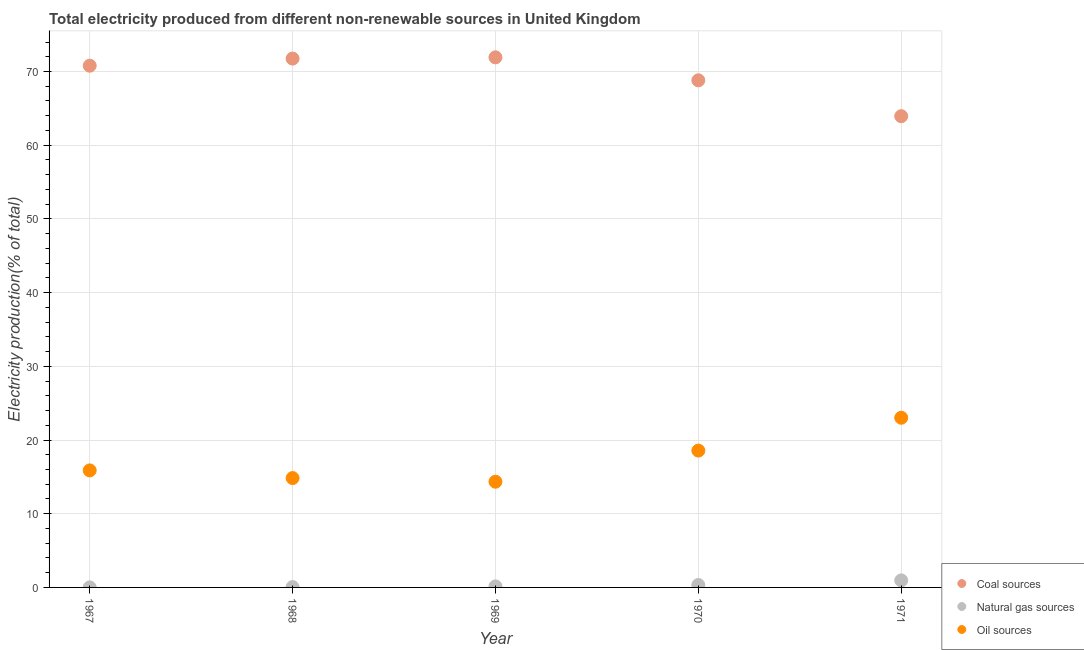How many different coloured dotlines are there?
Offer a very short reply. 3. What is the percentage of electricity produced by coal in 1970?
Your answer should be very brief. 68.81. Across all years, what is the maximum percentage of electricity produced by natural gas?
Provide a succinct answer. 0.96. Across all years, what is the minimum percentage of electricity produced by oil sources?
Provide a short and direct response. 14.34. In which year was the percentage of electricity produced by coal minimum?
Ensure brevity in your answer.  1971. What is the total percentage of electricity produced by natural gas in the graph?
Provide a short and direct response. 1.48. What is the difference between the percentage of electricity produced by coal in 1967 and that in 1971?
Your answer should be very brief. 6.85. What is the difference between the percentage of electricity produced by coal in 1967 and the percentage of electricity produced by oil sources in 1970?
Provide a succinct answer. 52.22. What is the average percentage of electricity produced by natural gas per year?
Your answer should be compact. 0.3. In the year 1968, what is the difference between the percentage of electricity produced by oil sources and percentage of electricity produced by coal?
Keep it short and to the point. -56.91. What is the ratio of the percentage of electricity produced by coal in 1967 to that in 1970?
Provide a short and direct response. 1.03. What is the difference between the highest and the second highest percentage of electricity produced by natural gas?
Your answer should be very brief. 0.62. What is the difference between the highest and the lowest percentage of electricity produced by natural gas?
Your response must be concise. 0.95. Is the sum of the percentage of electricity produced by coal in 1967 and 1968 greater than the maximum percentage of electricity produced by natural gas across all years?
Keep it short and to the point. Yes. Does the percentage of electricity produced by oil sources monotonically increase over the years?
Your answer should be compact. No. How many years are there in the graph?
Offer a terse response. 5. Are the values on the major ticks of Y-axis written in scientific E-notation?
Give a very brief answer. No. Does the graph contain any zero values?
Make the answer very short. No. Does the graph contain grids?
Ensure brevity in your answer.  Yes. How many legend labels are there?
Your answer should be compact. 3. How are the legend labels stacked?
Give a very brief answer. Vertical. What is the title of the graph?
Make the answer very short. Total electricity produced from different non-renewable sources in United Kingdom. What is the Electricity production(% of total) in Coal sources in 1967?
Ensure brevity in your answer.  70.79. What is the Electricity production(% of total) of Natural gas sources in 1967?
Make the answer very short. 0.01. What is the Electricity production(% of total) of Oil sources in 1967?
Ensure brevity in your answer.  15.88. What is the Electricity production(% of total) of Coal sources in 1968?
Ensure brevity in your answer.  71.75. What is the Electricity production(% of total) of Natural gas sources in 1968?
Give a very brief answer. 0.05. What is the Electricity production(% of total) of Oil sources in 1968?
Your response must be concise. 14.84. What is the Electricity production(% of total) in Coal sources in 1969?
Your answer should be very brief. 71.92. What is the Electricity production(% of total) in Natural gas sources in 1969?
Offer a terse response. 0.14. What is the Electricity production(% of total) in Oil sources in 1969?
Provide a short and direct response. 14.34. What is the Electricity production(% of total) of Coal sources in 1970?
Keep it short and to the point. 68.81. What is the Electricity production(% of total) in Natural gas sources in 1970?
Offer a very short reply. 0.33. What is the Electricity production(% of total) of Oil sources in 1970?
Your response must be concise. 18.57. What is the Electricity production(% of total) of Coal sources in 1971?
Provide a succinct answer. 63.94. What is the Electricity production(% of total) in Natural gas sources in 1971?
Keep it short and to the point. 0.96. What is the Electricity production(% of total) of Oil sources in 1971?
Your answer should be compact. 23.02. Across all years, what is the maximum Electricity production(% of total) in Coal sources?
Ensure brevity in your answer.  71.92. Across all years, what is the maximum Electricity production(% of total) in Natural gas sources?
Ensure brevity in your answer.  0.96. Across all years, what is the maximum Electricity production(% of total) in Oil sources?
Offer a very short reply. 23.02. Across all years, what is the minimum Electricity production(% of total) of Coal sources?
Provide a succinct answer. 63.94. Across all years, what is the minimum Electricity production(% of total) of Natural gas sources?
Keep it short and to the point. 0.01. Across all years, what is the minimum Electricity production(% of total) of Oil sources?
Offer a very short reply. 14.34. What is the total Electricity production(% of total) of Coal sources in the graph?
Give a very brief answer. 347.21. What is the total Electricity production(% of total) of Natural gas sources in the graph?
Provide a short and direct response. 1.48. What is the total Electricity production(% of total) in Oil sources in the graph?
Keep it short and to the point. 86.65. What is the difference between the Electricity production(% of total) in Coal sources in 1967 and that in 1968?
Keep it short and to the point. -0.96. What is the difference between the Electricity production(% of total) in Natural gas sources in 1967 and that in 1968?
Give a very brief answer. -0.04. What is the difference between the Electricity production(% of total) of Oil sources in 1967 and that in 1968?
Ensure brevity in your answer.  1.04. What is the difference between the Electricity production(% of total) of Coal sources in 1967 and that in 1969?
Your answer should be compact. -1.13. What is the difference between the Electricity production(% of total) of Natural gas sources in 1967 and that in 1969?
Make the answer very short. -0.14. What is the difference between the Electricity production(% of total) in Oil sources in 1967 and that in 1969?
Your answer should be very brief. 1.53. What is the difference between the Electricity production(% of total) of Coal sources in 1967 and that in 1970?
Make the answer very short. 1.98. What is the difference between the Electricity production(% of total) in Natural gas sources in 1967 and that in 1970?
Your response must be concise. -0.32. What is the difference between the Electricity production(% of total) of Oil sources in 1967 and that in 1970?
Your response must be concise. -2.69. What is the difference between the Electricity production(% of total) of Coal sources in 1967 and that in 1971?
Ensure brevity in your answer.  6.85. What is the difference between the Electricity production(% of total) of Natural gas sources in 1967 and that in 1971?
Your answer should be compact. -0.95. What is the difference between the Electricity production(% of total) in Oil sources in 1967 and that in 1971?
Make the answer very short. -7.15. What is the difference between the Electricity production(% of total) of Coal sources in 1968 and that in 1969?
Provide a short and direct response. -0.17. What is the difference between the Electricity production(% of total) of Natural gas sources in 1968 and that in 1969?
Offer a terse response. -0.09. What is the difference between the Electricity production(% of total) of Oil sources in 1968 and that in 1969?
Provide a short and direct response. 0.5. What is the difference between the Electricity production(% of total) in Coal sources in 1968 and that in 1970?
Make the answer very short. 2.95. What is the difference between the Electricity production(% of total) in Natural gas sources in 1968 and that in 1970?
Keep it short and to the point. -0.28. What is the difference between the Electricity production(% of total) of Oil sources in 1968 and that in 1970?
Give a very brief answer. -3.73. What is the difference between the Electricity production(% of total) of Coal sources in 1968 and that in 1971?
Give a very brief answer. 7.81. What is the difference between the Electricity production(% of total) in Natural gas sources in 1968 and that in 1971?
Offer a terse response. -0.91. What is the difference between the Electricity production(% of total) in Oil sources in 1968 and that in 1971?
Ensure brevity in your answer.  -8.18. What is the difference between the Electricity production(% of total) of Coal sources in 1969 and that in 1970?
Keep it short and to the point. 3.12. What is the difference between the Electricity production(% of total) in Natural gas sources in 1969 and that in 1970?
Offer a terse response. -0.19. What is the difference between the Electricity production(% of total) in Oil sources in 1969 and that in 1970?
Make the answer very short. -4.22. What is the difference between the Electricity production(% of total) in Coal sources in 1969 and that in 1971?
Offer a terse response. 7.99. What is the difference between the Electricity production(% of total) of Natural gas sources in 1969 and that in 1971?
Offer a terse response. -0.81. What is the difference between the Electricity production(% of total) of Oil sources in 1969 and that in 1971?
Offer a very short reply. -8.68. What is the difference between the Electricity production(% of total) of Coal sources in 1970 and that in 1971?
Ensure brevity in your answer.  4.87. What is the difference between the Electricity production(% of total) of Natural gas sources in 1970 and that in 1971?
Give a very brief answer. -0.62. What is the difference between the Electricity production(% of total) of Oil sources in 1970 and that in 1971?
Keep it short and to the point. -4.46. What is the difference between the Electricity production(% of total) of Coal sources in 1967 and the Electricity production(% of total) of Natural gas sources in 1968?
Your response must be concise. 70.74. What is the difference between the Electricity production(% of total) in Coal sources in 1967 and the Electricity production(% of total) in Oil sources in 1968?
Provide a succinct answer. 55.95. What is the difference between the Electricity production(% of total) of Natural gas sources in 1967 and the Electricity production(% of total) of Oil sources in 1968?
Make the answer very short. -14.83. What is the difference between the Electricity production(% of total) in Coal sources in 1967 and the Electricity production(% of total) in Natural gas sources in 1969?
Offer a very short reply. 70.65. What is the difference between the Electricity production(% of total) of Coal sources in 1967 and the Electricity production(% of total) of Oil sources in 1969?
Ensure brevity in your answer.  56.45. What is the difference between the Electricity production(% of total) in Natural gas sources in 1967 and the Electricity production(% of total) in Oil sources in 1969?
Keep it short and to the point. -14.34. What is the difference between the Electricity production(% of total) in Coal sources in 1967 and the Electricity production(% of total) in Natural gas sources in 1970?
Provide a succinct answer. 70.46. What is the difference between the Electricity production(% of total) in Coal sources in 1967 and the Electricity production(% of total) in Oil sources in 1970?
Offer a terse response. 52.22. What is the difference between the Electricity production(% of total) of Natural gas sources in 1967 and the Electricity production(% of total) of Oil sources in 1970?
Provide a short and direct response. -18.56. What is the difference between the Electricity production(% of total) of Coal sources in 1967 and the Electricity production(% of total) of Natural gas sources in 1971?
Offer a very short reply. 69.83. What is the difference between the Electricity production(% of total) of Coal sources in 1967 and the Electricity production(% of total) of Oil sources in 1971?
Your answer should be compact. 47.77. What is the difference between the Electricity production(% of total) of Natural gas sources in 1967 and the Electricity production(% of total) of Oil sources in 1971?
Make the answer very short. -23.02. What is the difference between the Electricity production(% of total) in Coal sources in 1968 and the Electricity production(% of total) in Natural gas sources in 1969?
Give a very brief answer. 71.61. What is the difference between the Electricity production(% of total) in Coal sources in 1968 and the Electricity production(% of total) in Oil sources in 1969?
Your answer should be very brief. 57.41. What is the difference between the Electricity production(% of total) of Natural gas sources in 1968 and the Electricity production(% of total) of Oil sources in 1969?
Provide a succinct answer. -14.29. What is the difference between the Electricity production(% of total) in Coal sources in 1968 and the Electricity production(% of total) in Natural gas sources in 1970?
Your answer should be compact. 71.42. What is the difference between the Electricity production(% of total) in Coal sources in 1968 and the Electricity production(% of total) in Oil sources in 1970?
Your answer should be very brief. 53.18. What is the difference between the Electricity production(% of total) in Natural gas sources in 1968 and the Electricity production(% of total) in Oil sources in 1970?
Provide a short and direct response. -18.52. What is the difference between the Electricity production(% of total) in Coal sources in 1968 and the Electricity production(% of total) in Natural gas sources in 1971?
Your answer should be very brief. 70.8. What is the difference between the Electricity production(% of total) in Coal sources in 1968 and the Electricity production(% of total) in Oil sources in 1971?
Provide a short and direct response. 48.73. What is the difference between the Electricity production(% of total) of Natural gas sources in 1968 and the Electricity production(% of total) of Oil sources in 1971?
Give a very brief answer. -22.98. What is the difference between the Electricity production(% of total) in Coal sources in 1969 and the Electricity production(% of total) in Natural gas sources in 1970?
Offer a very short reply. 71.59. What is the difference between the Electricity production(% of total) of Coal sources in 1969 and the Electricity production(% of total) of Oil sources in 1970?
Your answer should be very brief. 53.36. What is the difference between the Electricity production(% of total) of Natural gas sources in 1969 and the Electricity production(% of total) of Oil sources in 1970?
Provide a short and direct response. -18.42. What is the difference between the Electricity production(% of total) in Coal sources in 1969 and the Electricity production(% of total) in Natural gas sources in 1971?
Provide a short and direct response. 70.97. What is the difference between the Electricity production(% of total) in Coal sources in 1969 and the Electricity production(% of total) in Oil sources in 1971?
Provide a succinct answer. 48.9. What is the difference between the Electricity production(% of total) of Natural gas sources in 1969 and the Electricity production(% of total) of Oil sources in 1971?
Keep it short and to the point. -22.88. What is the difference between the Electricity production(% of total) of Coal sources in 1970 and the Electricity production(% of total) of Natural gas sources in 1971?
Your answer should be very brief. 67.85. What is the difference between the Electricity production(% of total) of Coal sources in 1970 and the Electricity production(% of total) of Oil sources in 1971?
Offer a very short reply. 45.78. What is the difference between the Electricity production(% of total) in Natural gas sources in 1970 and the Electricity production(% of total) in Oil sources in 1971?
Provide a short and direct response. -22.69. What is the average Electricity production(% of total) of Coal sources per year?
Your response must be concise. 69.44. What is the average Electricity production(% of total) of Natural gas sources per year?
Your answer should be compact. 0.3. What is the average Electricity production(% of total) in Oil sources per year?
Offer a terse response. 17.33. In the year 1967, what is the difference between the Electricity production(% of total) in Coal sources and Electricity production(% of total) in Natural gas sources?
Make the answer very short. 70.78. In the year 1967, what is the difference between the Electricity production(% of total) of Coal sources and Electricity production(% of total) of Oil sources?
Provide a succinct answer. 54.91. In the year 1967, what is the difference between the Electricity production(% of total) in Natural gas sources and Electricity production(% of total) in Oil sources?
Ensure brevity in your answer.  -15.87. In the year 1968, what is the difference between the Electricity production(% of total) of Coal sources and Electricity production(% of total) of Natural gas sources?
Offer a very short reply. 71.7. In the year 1968, what is the difference between the Electricity production(% of total) of Coal sources and Electricity production(% of total) of Oil sources?
Your response must be concise. 56.91. In the year 1968, what is the difference between the Electricity production(% of total) of Natural gas sources and Electricity production(% of total) of Oil sources?
Offer a very short reply. -14.79. In the year 1969, what is the difference between the Electricity production(% of total) of Coal sources and Electricity production(% of total) of Natural gas sources?
Ensure brevity in your answer.  71.78. In the year 1969, what is the difference between the Electricity production(% of total) in Coal sources and Electricity production(% of total) in Oil sources?
Your answer should be compact. 57.58. In the year 1969, what is the difference between the Electricity production(% of total) in Natural gas sources and Electricity production(% of total) in Oil sources?
Make the answer very short. -14.2. In the year 1970, what is the difference between the Electricity production(% of total) of Coal sources and Electricity production(% of total) of Natural gas sources?
Your answer should be very brief. 68.47. In the year 1970, what is the difference between the Electricity production(% of total) of Coal sources and Electricity production(% of total) of Oil sources?
Offer a very short reply. 50.24. In the year 1970, what is the difference between the Electricity production(% of total) in Natural gas sources and Electricity production(% of total) in Oil sources?
Make the answer very short. -18.23. In the year 1971, what is the difference between the Electricity production(% of total) of Coal sources and Electricity production(% of total) of Natural gas sources?
Provide a succinct answer. 62.98. In the year 1971, what is the difference between the Electricity production(% of total) of Coal sources and Electricity production(% of total) of Oil sources?
Ensure brevity in your answer.  40.91. In the year 1971, what is the difference between the Electricity production(% of total) in Natural gas sources and Electricity production(% of total) in Oil sources?
Your response must be concise. -22.07. What is the ratio of the Electricity production(% of total) in Coal sources in 1967 to that in 1968?
Offer a very short reply. 0.99. What is the ratio of the Electricity production(% of total) of Natural gas sources in 1967 to that in 1968?
Offer a very short reply. 0.15. What is the ratio of the Electricity production(% of total) of Oil sources in 1967 to that in 1968?
Keep it short and to the point. 1.07. What is the ratio of the Electricity production(% of total) in Coal sources in 1967 to that in 1969?
Provide a short and direct response. 0.98. What is the ratio of the Electricity production(% of total) in Natural gas sources in 1967 to that in 1969?
Provide a short and direct response. 0.05. What is the ratio of the Electricity production(% of total) in Oil sources in 1967 to that in 1969?
Your answer should be compact. 1.11. What is the ratio of the Electricity production(% of total) of Coal sources in 1967 to that in 1970?
Your response must be concise. 1.03. What is the ratio of the Electricity production(% of total) in Natural gas sources in 1967 to that in 1970?
Your response must be concise. 0.02. What is the ratio of the Electricity production(% of total) in Oil sources in 1967 to that in 1970?
Make the answer very short. 0.86. What is the ratio of the Electricity production(% of total) in Coal sources in 1967 to that in 1971?
Provide a succinct answer. 1.11. What is the ratio of the Electricity production(% of total) of Natural gas sources in 1967 to that in 1971?
Provide a short and direct response. 0.01. What is the ratio of the Electricity production(% of total) of Oil sources in 1967 to that in 1971?
Give a very brief answer. 0.69. What is the ratio of the Electricity production(% of total) of Coal sources in 1968 to that in 1969?
Ensure brevity in your answer.  1. What is the ratio of the Electricity production(% of total) of Natural gas sources in 1968 to that in 1969?
Give a very brief answer. 0.34. What is the ratio of the Electricity production(% of total) of Oil sources in 1968 to that in 1969?
Your answer should be compact. 1.03. What is the ratio of the Electricity production(% of total) in Coal sources in 1968 to that in 1970?
Offer a terse response. 1.04. What is the ratio of the Electricity production(% of total) in Natural gas sources in 1968 to that in 1970?
Provide a succinct answer. 0.14. What is the ratio of the Electricity production(% of total) of Oil sources in 1968 to that in 1970?
Your answer should be very brief. 0.8. What is the ratio of the Electricity production(% of total) of Coal sources in 1968 to that in 1971?
Make the answer very short. 1.12. What is the ratio of the Electricity production(% of total) of Natural gas sources in 1968 to that in 1971?
Ensure brevity in your answer.  0.05. What is the ratio of the Electricity production(% of total) in Oil sources in 1968 to that in 1971?
Your response must be concise. 0.64. What is the ratio of the Electricity production(% of total) in Coal sources in 1969 to that in 1970?
Offer a terse response. 1.05. What is the ratio of the Electricity production(% of total) of Natural gas sources in 1969 to that in 1970?
Offer a terse response. 0.43. What is the ratio of the Electricity production(% of total) of Oil sources in 1969 to that in 1970?
Give a very brief answer. 0.77. What is the ratio of the Electricity production(% of total) in Coal sources in 1969 to that in 1971?
Your response must be concise. 1.12. What is the ratio of the Electricity production(% of total) in Natural gas sources in 1969 to that in 1971?
Your answer should be very brief. 0.15. What is the ratio of the Electricity production(% of total) of Oil sources in 1969 to that in 1971?
Keep it short and to the point. 0.62. What is the ratio of the Electricity production(% of total) of Coal sources in 1970 to that in 1971?
Offer a very short reply. 1.08. What is the ratio of the Electricity production(% of total) in Natural gas sources in 1970 to that in 1971?
Keep it short and to the point. 0.35. What is the ratio of the Electricity production(% of total) of Oil sources in 1970 to that in 1971?
Your answer should be very brief. 0.81. What is the difference between the highest and the second highest Electricity production(% of total) in Coal sources?
Give a very brief answer. 0.17. What is the difference between the highest and the second highest Electricity production(% of total) of Natural gas sources?
Ensure brevity in your answer.  0.62. What is the difference between the highest and the second highest Electricity production(% of total) in Oil sources?
Provide a short and direct response. 4.46. What is the difference between the highest and the lowest Electricity production(% of total) in Coal sources?
Offer a terse response. 7.99. What is the difference between the highest and the lowest Electricity production(% of total) in Natural gas sources?
Ensure brevity in your answer.  0.95. What is the difference between the highest and the lowest Electricity production(% of total) of Oil sources?
Your response must be concise. 8.68. 